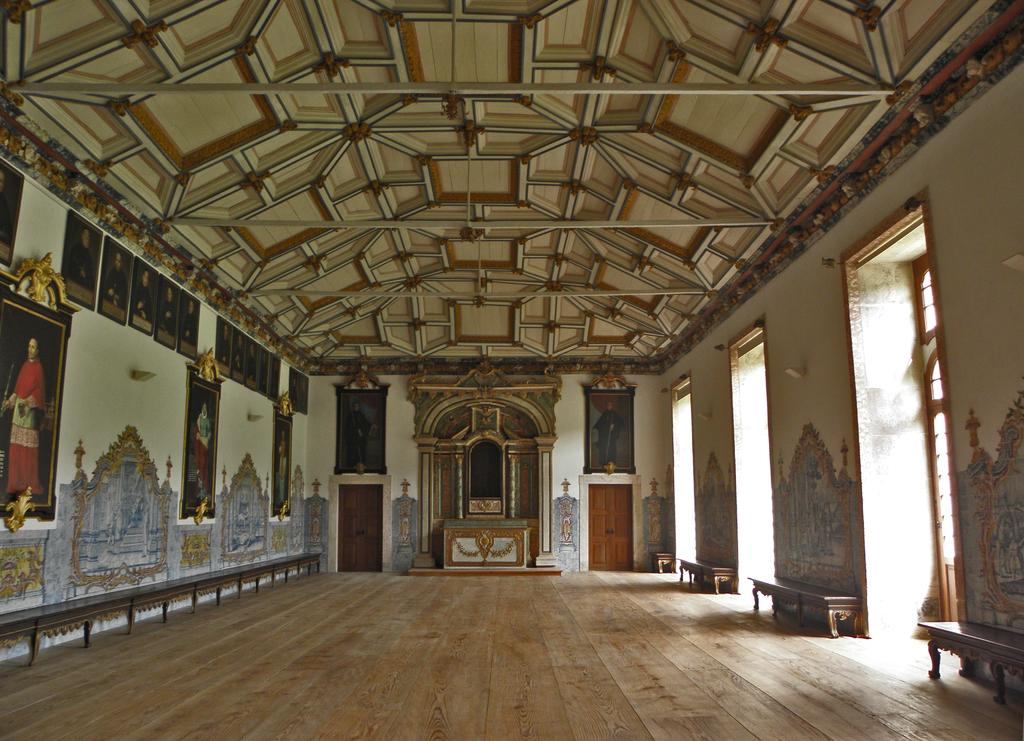What type of space is depicted in the image? The image shows an interior view of a hall. What can be seen on the walls of the hall? There are frames attached to the walls, and there is art on the walls. Are there any openings to the outside in the image? Yes, there are doors and windows in the image. What type of furniture is present in the hall? There are benches in the image. What type of silver material can be seen on the benches in the image? There is no silver material visible on the benches in the image. What type of shocking event is taking place in the image? There is no shocking event depicted in the image; it shows a peaceful interior view of a hall. 